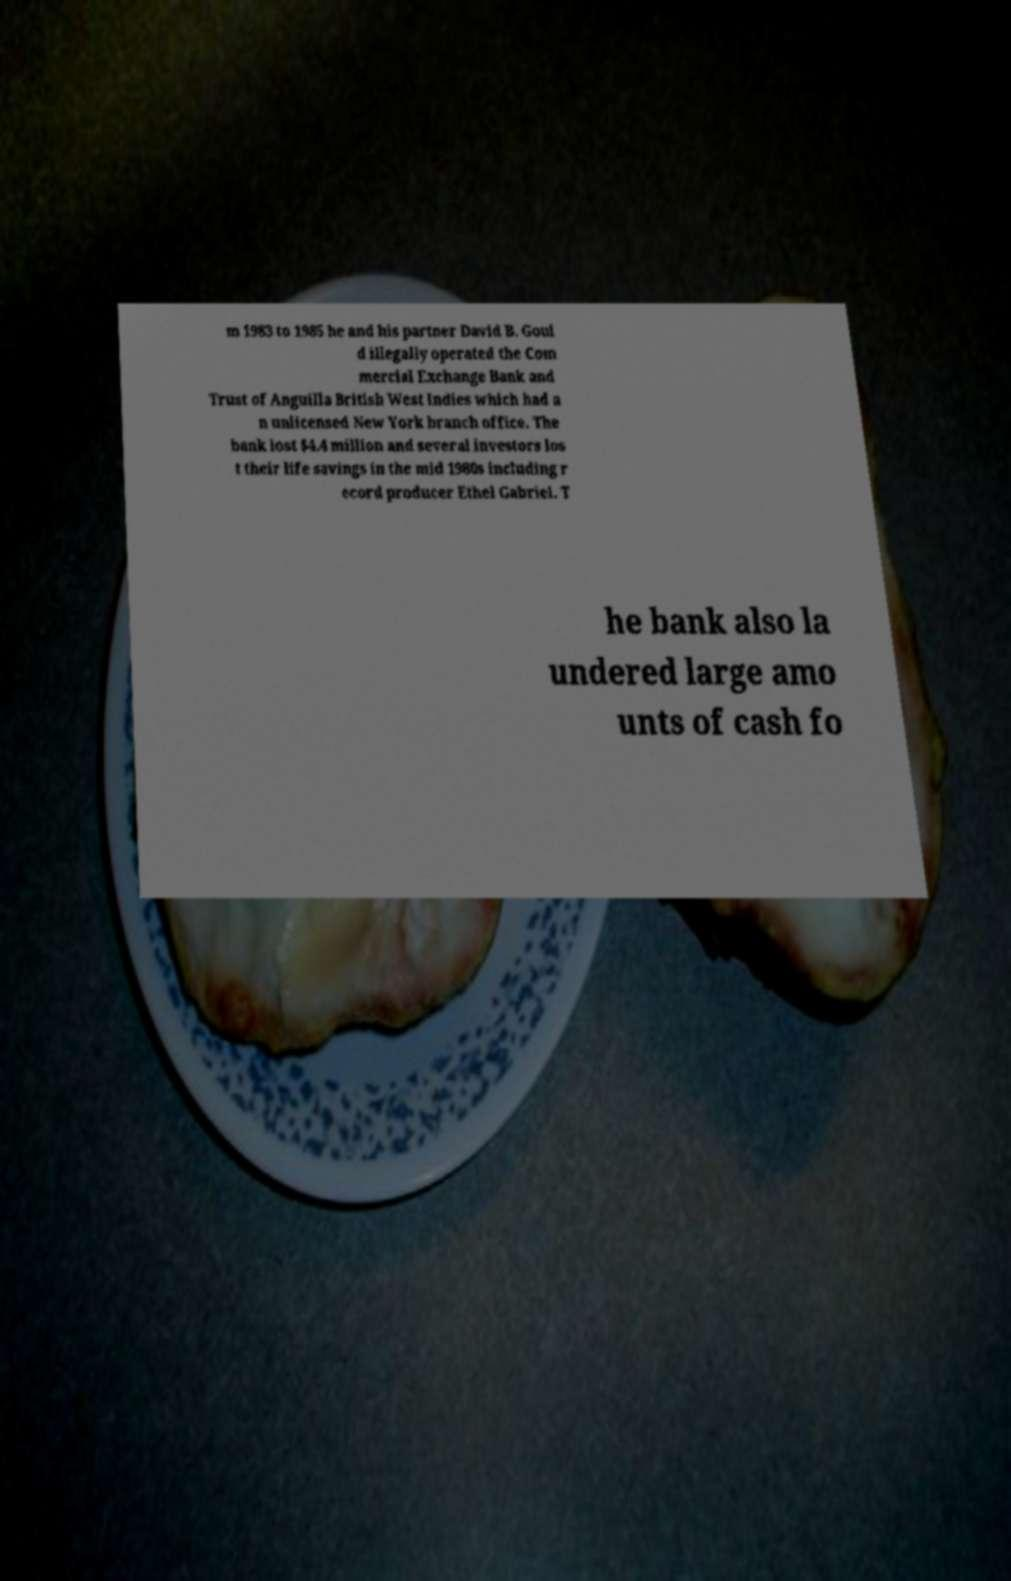There's text embedded in this image that I need extracted. Can you transcribe it verbatim? m 1983 to 1985 he and his partner David B. Goul d illegally operated the Com mercial Exchange Bank and Trust of Anguilla British West Indies which had a n unlicensed New York branch office. The bank lost $4.4 million and several investors los t their life savings in the mid 1980s including r ecord producer Ethel Gabriel. T he bank also la undered large amo unts of cash fo 